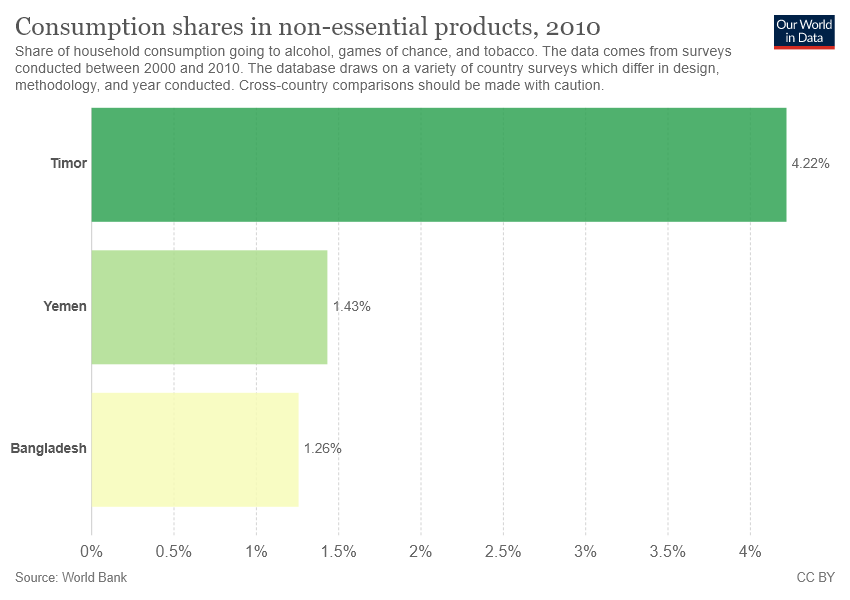Mention a couple of crucial points in this snapshot. The average of the smallest two bars is 1.345... Timor is the country that has the longest bar. 